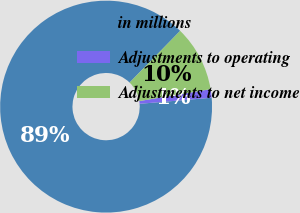Convert chart. <chart><loc_0><loc_0><loc_500><loc_500><pie_chart><fcel>in millions<fcel>Adjustments to operating<fcel>Adjustments to net income<nl><fcel>88.66%<fcel>1.3%<fcel>10.04%<nl></chart> 